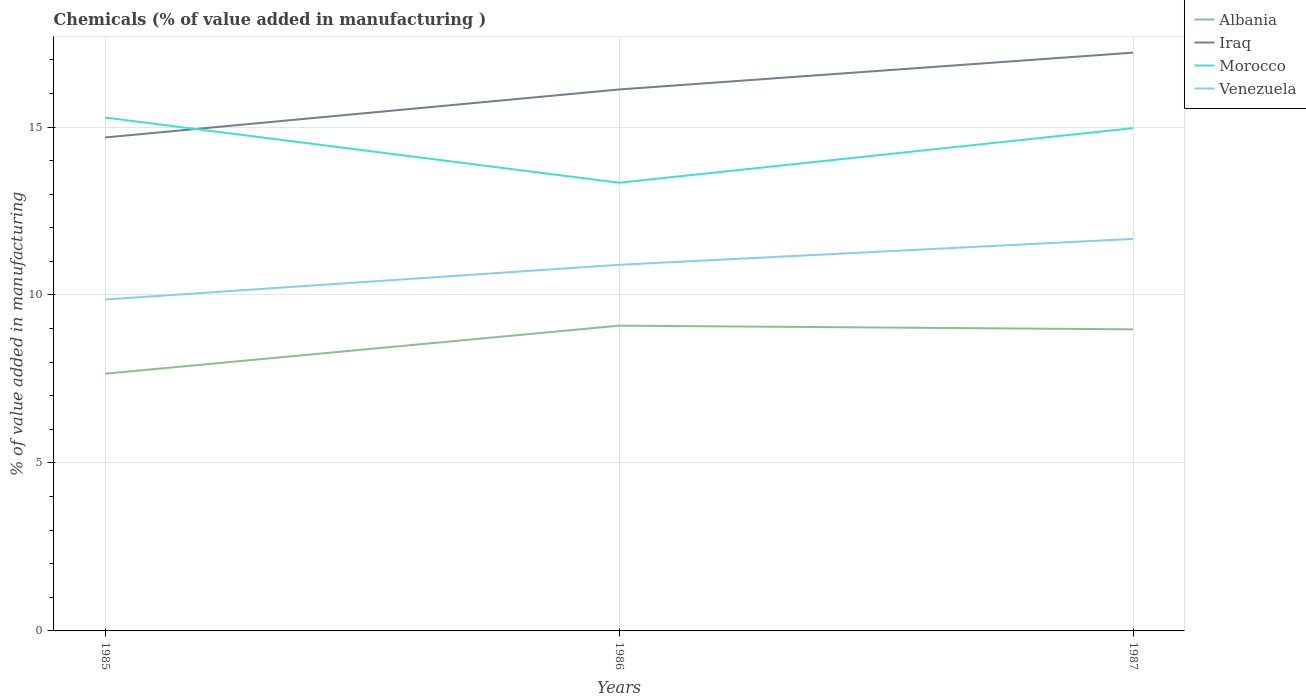How many different coloured lines are there?
Offer a terse response. 4. Does the line corresponding to Iraq intersect with the line corresponding to Albania?
Offer a terse response. No. Across all years, what is the maximum value added in manufacturing chemicals in Morocco?
Your answer should be very brief. 13.34. What is the total value added in manufacturing chemicals in Morocco in the graph?
Offer a very short reply. 1.94. What is the difference between the highest and the second highest value added in manufacturing chemicals in Albania?
Offer a very short reply. 1.43. How many years are there in the graph?
Give a very brief answer. 3. What is the difference between two consecutive major ticks on the Y-axis?
Provide a succinct answer. 5. Does the graph contain grids?
Give a very brief answer. Yes. Where does the legend appear in the graph?
Your answer should be compact. Top right. How are the legend labels stacked?
Offer a very short reply. Vertical. What is the title of the graph?
Keep it short and to the point. Chemicals (% of value added in manufacturing ). What is the label or title of the X-axis?
Keep it short and to the point. Years. What is the label or title of the Y-axis?
Your response must be concise. % of value added in manufacturing. What is the % of value added in manufacturing in Albania in 1985?
Your answer should be very brief. 7.66. What is the % of value added in manufacturing in Iraq in 1985?
Your answer should be very brief. 14.69. What is the % of value added in manufacturing of Morocco in 1985?
Provide a short and direct response. 15.28. What is the % of value added in manufacturing in Venezuela in 1985?
Provide a succinct answer. 9.87. What is the % of value added in manufacturing of Albania in 1986?
Provide a succinct answer. 9.09. What is the % of value added in manufacturing in Iraq in 1986?
Your answer should be very brief. 16.12. What is the % of value added in manufacturing in Morocco in 1986?
Offer a very short reply. 13.34. What is the % of value added in manufacturing of Venezuela in 1986?
Provide a short and direct response. 10.9. What is the % of value added in manufacturing of Albania in 1987?
Your response must be concise. 8.98. What is the % of value added in manufacturing in Iraq in 1987?
Offer a terse response. 17.21. What is the % of value added in manufacturing in Morocco in 1987?
Offer a terse response. 14.97. What is the % of value added in manufacturing in Venezuela in 1987?
Provide a short and direct response. 11.67. Across all years, what is the maximum % of value added in manufacturing of Albania?
Provide a succinct answer. 9.09. Across all years, what is the maximum % of value added in manufacturing of Iraq?
Provide a succinct answer. 17.21. Across all years, what is the maximum % of value added in manufacturing of Morocco?
Your answer should be compact. 15.28. Across all years, what is the maximum % of value added in manufacturing in Venezuela?
Provide a short and direct response. 11.67. Across all years, what is the minimum % of value added in manufacturing of Albania?
Ensure brevity in your answer.  7.66. Across all years, what is the minimum % of value added in manufacturing of Iraq?
Your answer should be compact. 14.69. Across all years, what is the minimum % of value added in manufacturing in Morocco?
Make the answer very short. 13.34. Across all years, what is the minimum % of value added in manufacturing of Venezuela?
Ensure brevity in your answer.  9.87. What is the total % of value added in manufacturing in Albania in the graph?
Your answer should be very brief. 25.72. What is the total % of value added in manufacturing in Iraq in the graph?
Make the answer very short. 48.02. What is the total % of value added in manufacturing of Morocco in the graph?
Your answer should be very brief. 43.59. What is the total % of value added in manufacturing in Venezuela in the graph?
Make the answer very short. 32.43. What is the difference between the % of value added in manufacturing of Albania in 1985 and that in 1986?
Provide a succinct answer. -1.43. What is the difference between the % of value added in manufacturing in Iraq in 1985 and that in 1986?
Give a very brief answer. -1.43. What is the difference between the % of value added in manufacturing in Morocco in 1985 and that in 1986?
Your response must be concise. 1.94. What is the difference between the % of value added in manufacturing in Venezuela in 1985 and that in 1986?
Offer a very short reply. -1.03. What is the difference between the % of value added in manufacturing in Albania in 1985 and that in 1987?
Offer a very short reply. -1.32. What is the difference between the % of value added in manufacturing of Iraq in 1985 and that in 1987?
Offer a very short reply. -2.52. What is the difference between the % of value added in manufacturing in Morocco in 1985 and that in 1987?
Your answer should be very brief. 0.32. What is the difference between the % of value added in manufacturing of Venezuela in 1985 and that in 1987?
Your answer should be compact. -1.8. What is the difference between the % of value added in manufacturing in Albania in 1986 and that in 1987?
Keep it short and to the point. 0.11. What is the difference between the % of value added in manufacturing of Iraq in 1986 and that in 1987?
Offer a very short reply. -1.1. What is the difference between the % of value added in manufacturing in Morocco in 1986 and that in 1987?
Provide a succinct answer. -1.63. What is the difference between the % of value added in manufacturing of Venezuela in 1986 and that in 1987?
Your response must be concise. -0.77. What is the difference between the % of value added in manufacturing in Albania in 1985 and the % of value added in manufacturing in Iraq in 1986?
Provide a succinct answer. -8.46. What is the difference between the % of value added in manufacturing of Albania in 1985 and the % of value added in manufacturing of Morocco in 1986?
Offer a terse response. -5.68. What is the difference between the % of value added in manufacturing in Albania in 1985 and the % of value added in manufacturing in Venezuela in 1986?
Your answer should be very brief. -3.24. What is the difference between the % of value added in manufacturing in Iraq in 1985 and the % of value added in manufacturing in Morocco in 1986?
Provide a short and direct response. 1.35. What is the difference between the % of value added in manufacturing of Iraq in 1985 and the % of value added in manufacturing of Venezuela in 1986?
Provide a succinct answer. 3.79. What is the difference between the % of value added in manufacturing of Morocco in 1985 and the % of value added in manufacturing of Venezuela in 1986?
Your answer should be very brief. 4.38. What is the difference between the % of value added in manufacturing of Albania in 1985 and the % of value added in manufacturing of Iraq in 1987?
Provide a succinct answer. -9.56. What is the difference between the % of value added in manufacturing of Albania in 1985 and the % of value added in manufacturing of Morocco in 1987?
Your response must be concise. -7.31. What is the difference between the % of value added in manufacturing in Albania in 1985 and the % of value added in manufacturing in Venezuela in 1987?
Ensure brevity in your answer.  -4.01. What is the difference between the % of value added in manufacturing of Iraq in 1985 and the % of value added in manufacturing of Morocco in 1987?
Make the answer very short. -0.28. What is the difference between the % of value added in manufacturing in Iraq in 1985 and the % of value added in manufacturing in Venezuela in 1987?
Provide a short and direct response. 3.02. What is the difference between the % of value added in manufacturing in Morocco in 1985 and the % of value added in manufacturing in Venezuela in 1987?
Your response must be concise. 3.61. What is the difference between the % of value added in manufacturing in Albania in 1986 and the % of value added in manufacturing in Iraq in 1987?
Offer a very short reply. -8.13. What is the difference between the % of value added in manufacturing of Albania in 1986 and the % of value added in manufacturing of Morocco in 1987?
Give a very brief answer. -5.88. What is the difference between the % of value added in manufacturing in Albania in 1986 and the % of value added in manufacturing in Venezuela in 1987?
Provide a succinct answer. -2.58. What is the difference between the % of value added in manufacturing of Iraq in 1986 and the % of value added in manufacturing of Morocco in 1987?
Offer a terse response. 1.15. What is the difference between the % of value added in manufacturing of Iraq in 1986 and the % of value added in manufacturing of Venezuela in 1987?
Give a very brief answer. 4.45. What is the difference between the % of value added in manufacturing in Morocco in 1986 and the % of value added in manufacturing in Venezuela in 1987?
Offer a very short reply. 1.67. What is the average % of value added in manufacturing in Albania per year?
Offer a terse response. 8.57. What is the average % of value added in manufacturing in Iraq per year?
Offer a terse response. 16.01. What is the average % of value added in manufacturing in Morocco per year?
Ensure brevity in your answer.  14.53. What is the average % of value added in manufacturing in Venezuela per year?
Your answer should be very brief. 10.81. In the year 1985, what is the difference between the % of value added in manufacturing of Albania and % of value added in manufacturing of Iraq?
Keep it short and to the point. -7.03. In the year 1985, what is the difference between the % of value added in manufacturing of Albania and % of value added in manufacturing of Morocco?
Give a very brief answer. -7.63. In the year 1985, what is the difference between the % of value added in manufacturing in Albania and % of value added in manufacturing in Venezuela?
Your response must be concise. -2.21. In the year 1985, what is the difference between the % of value added in manufacturing in Iraq and % of value added in manufacturing in Morocco?
Your answer should be compact. -0.59. In the year 1985, what is the difference between the % of value added in manufacturing of Iraq and % of value added in manufacturing of Venezuela?
Ensure brevity in your answer.  4.82. In the year 1985, what is the difference between the % of value added in manufacturing in Morocco and % of value added in manufacturing in Venezuela?
Provide a succinct answer. 5.42. In the year 1986, what is the difference between the % of value added in manufacturing of Albania and % of value added in manufacturing of Iraq?
Make the answer very short. -7.03. In the year 1986, what is the difference between the % of value added in manufacturing in Albania and % of value added in manufacturing in Morocco?
Provide a succinct answer. -4.25. In the year 1986, what is the difference between the % of value added in manufacturing of Albania and % of value added in manufacturing of Venezuela?
Your answer should be very brief. -1.81. In the year 1986, what is the difference between the % of value added in manufacturing in Iraq and % of value added in manufacturing in Morocco?
Your answer should be compact. 2.78. In the year 1986, what is the difference between the % of value added in manufacturing of Iraq and % of value added in manufacturing of Venezuela?
Your answer should be very brief. 5.22. In the year 1986, what is the difference between the % of value added in manufacturing in Morocco and % of value added in manufacturing in Venezuela?
Ensure brevity in your answer.  2.44. In the year 1987, what is the difference between the % of value added in manufacturing in Albania and % of value added in manufacturing in Iraq?
Provide a succinct answer. -8.24. In the year 1987, what is the difference between the % of value added in manufacturing in Albania and % of value added in manufacturing in Morocco?
Give a very brief answer. -5.99. In the year 1987, what is the difference between the % of value added in manufacturing of Albania and % of value added in manufacturing of Venezuela?
Offer a very short reply. -2.69. In the year 1987, what is the difference between the % of value added in manufacturing of Iraq and % of value added in manufacturing of Morocco?
Keep it short and to the point. 2.25. In the year 1987, what is the difference between the % of value added in manufacturing of Iraq and % of value added in manufacturing of Venezuela?
Your answer should be compact. 5.54. In the year 1987, what is the difference between the % of value added in manufacturing in Morocco and % of value added in manufacturing in Venezuela?
Keep it short and to the point. 3.3. What is the ratio of the % of value added in manufacturing in Albania in 1985 to that in 1986?
Your answer should be compact. 0.84. What is the ratio of the % of value added in manufacturing in Iraq in 1985 to that in 1986?
Give a very brief answer. 0.91. What is the ratio of the % of value added in manufacturing in Morocco in 1985 to that in 1986?
Make the answer very short. 1.15. What is the ratio of the % of value added in manufacturing in Venezuela in 1985 to that in 1986?
Your answer should be very brief. 0.91. What is the ratio of the % of value added in manufacturing in Albania in 1985 to that in 1987?
Your response must be concise. 0.85. What is the ratio of the % of value added in manufacturing of Iraq in 1985 to that in 1987?
Ensure brevity in your answer.  0.85. What is the ratio of the % of value added in manufacturing of Morocco in 1985 to that in 1987?
Offer a terse response. 1.02. What is the ratio of the % of value added in manufacturing of Venezuela in 1985 to that in 1987?
Make the answer very short. 0.85. What is the ratio of the % of value added in manufacturing in Albania in 1986 to that in 1987?
Give a very brief answer. 1.01. What is the ratio of the % of value added in manufacturing of Iraq in 1986 to that in 1987?
Ensure brevity in your answer.  0.94. What is the ratio of the % of value added in manufacturing in Morocco in 1986 to that in 1987?
Your response must be concise. 0.89. What is the ratio of the % of value added in manufacturing in Venezuela in 1986 to that in 1987?
Provide a succinct answer. 0.93. What is the difference between the highest and the second highest % of value added in manufacturing of Albania?
Your answer should be compact. 0.11. What is the difference between the highest and the second highest % of value added in manufacturing of Iraq?
Provide a succinct answer. 1.1. What is the difference between the highest and the second highest % of value added in manufacturing of Morocco?
Offer a very short reply. 0.32. What is the difference between the highest and the second highest % of value added in manufacturing of Venezuela?
Give a very brief answer. 0.77. What is the difference between the highest and the lowest % of value added in manufacturing in Albania?
Make the answer very short. 1.43. What is the difference between the highest and the lowest % of value added in manufacturing in Iraq?
Provide a short and direct response. 2.52. What is the difference between the highest and the lowest % of value added in manufacturing of Morocco?
Keep it short and to the point. 1.94. What is the difference between the highest and the lowest % of value added in manufacturing in Venezuela?
Keep it short and to the point. 1.8. 